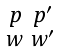<formula> <loc_0><loc_0><loc_500><loc_500>\begin{smallmatrix} p & p ^ { \prime } \\ w & w ^ { \prime } \end{smallmatrix}</formula> 